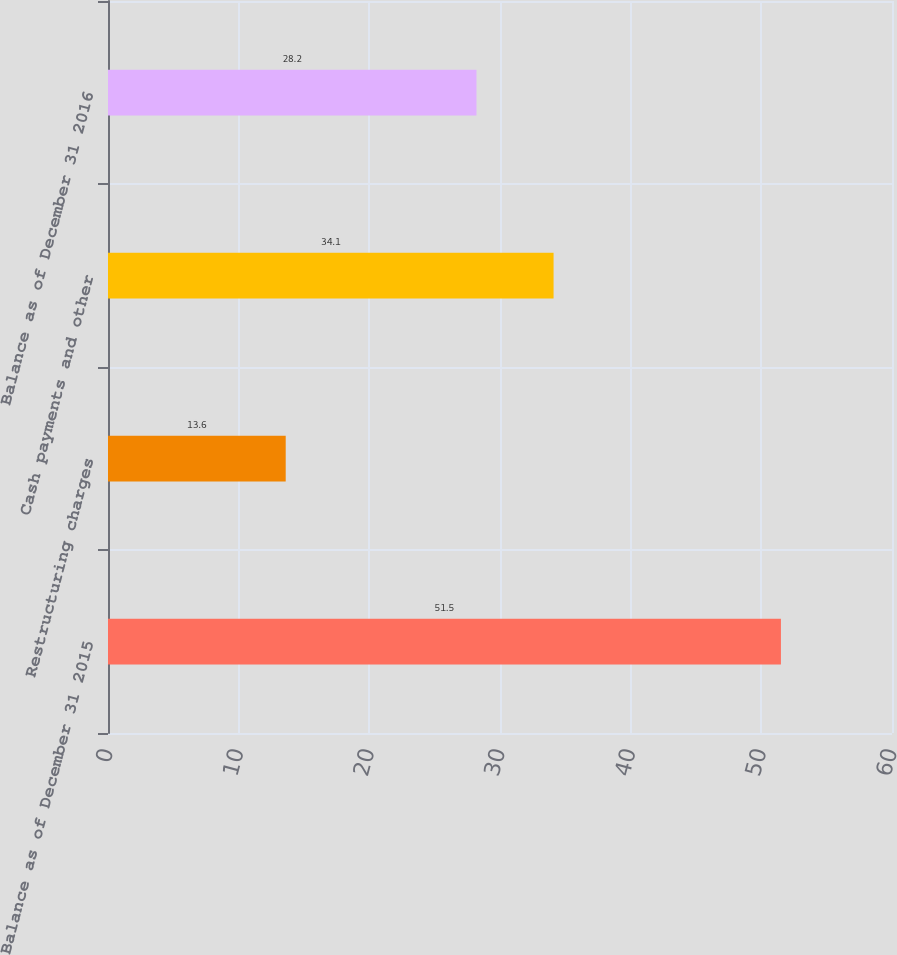<chart> <loc_0><loc_0><loc_500><loc_500><bar_chart><fcel>Balance as of December 31 2015<fcel>Restructuring charges<fcel>Cash payments and other<fcel>Balance as of December 31 2016<nl><fcel>51.5<fcel>13.6<fcel>34.1<fcel>28.2<nl></chart> 